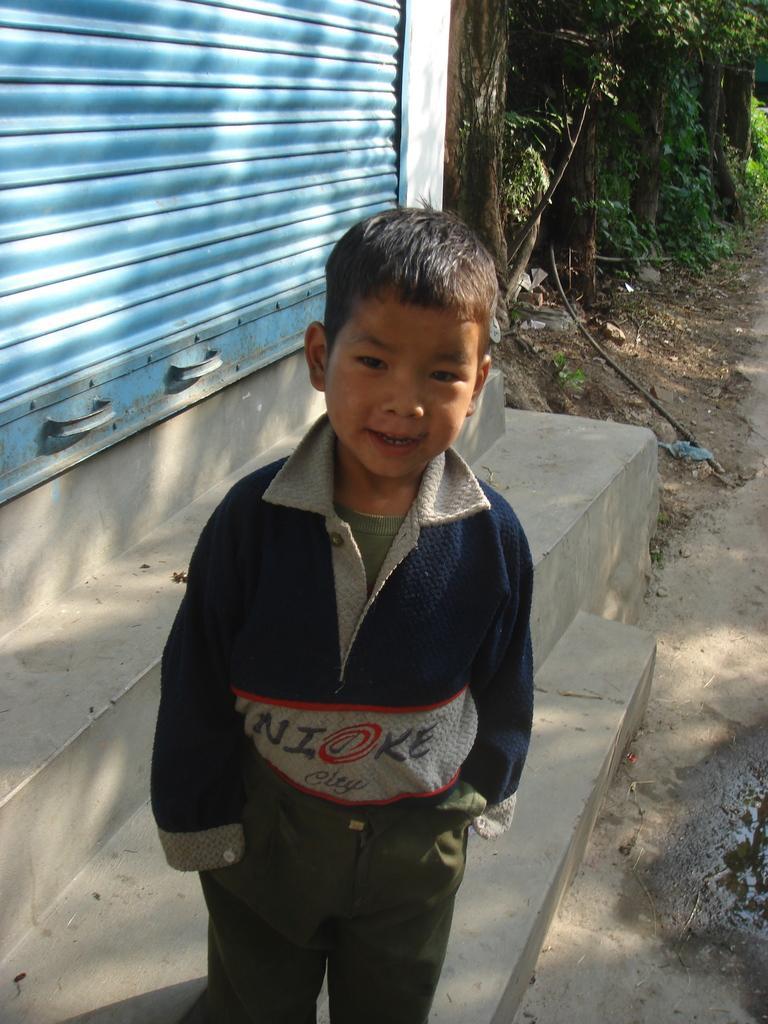Describe this image in one or two sentences. The boy in front of the picture wearing a blue T-shirt is standing. He is smiling. Beside him, we see a rolling shutter in blue color. In the background, there are trees. At the bottom, we see the road. 